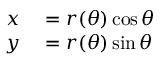Convert formula to latex. <formula><loc_0><loc_0><loc_500><loc_500>\begin{array} { r l } { x } & = r ( \theta ) \cos \theta } \\ { y } & = r ( \theta ) \sin \theta } \end{array}</formula> 